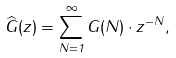Convert formula to latex. <formula><loc_0><loc_0><loc_500><loc_500>\widehat { G } ( z ) = \sum _ { N = 1 } ^ { \infty } G ( N ) \cdot z ^ { - N } ,</formula> 